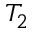Convert formula to latex. <formula><loc_0><loc_0><loc_500><loc_500>T _ { 2 }</formula> 